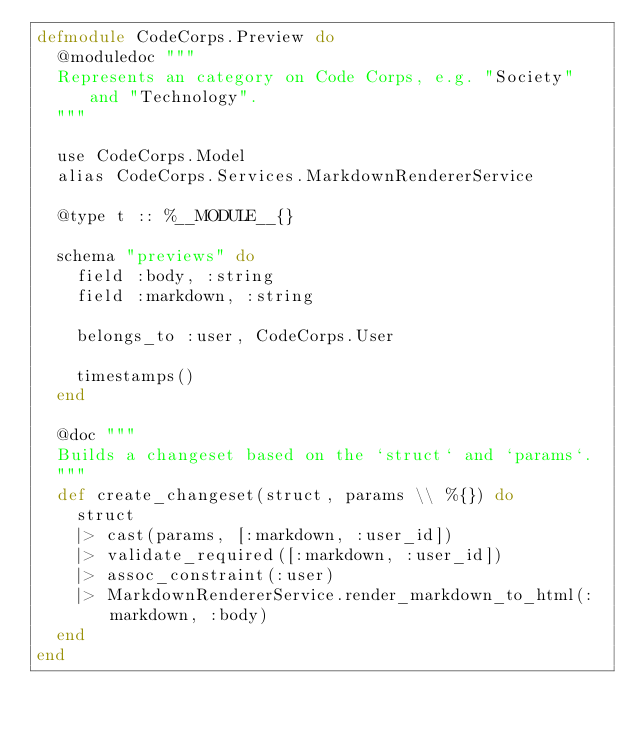Convert code to text. <code><loc_0><loc_0><loc_500><loc_500><_Elixir_>defmodule CodeCorps.Preview do
  @moduledoc """
  Represents an category on Code Corps, e.g. "Society" and "Technology".
  """

  use CodeCorps.Model
  alias CodeCorps.Services.MarkdownRendererService

  @type t :: %__MODULE__{}

  schema "previews" do
    field :body, :string
    field :markdown, :string

    belongs_to :user, CodeCorps.User

    timestamps()
  end

  @doc """
  Builds a changeset based on the `struct` and `params`.
  """
  def create_changeset(struct, params \\ %{}) do
    struct
    |> cast(params, [:markdown, :user_id])
    |> validate_required([:markdown, :user_id])
    |> assoc_constraint(:user)
    |> MarkdownRendererService.render_markdown_to_html(:markdown, :body)
  end
end
</code> 